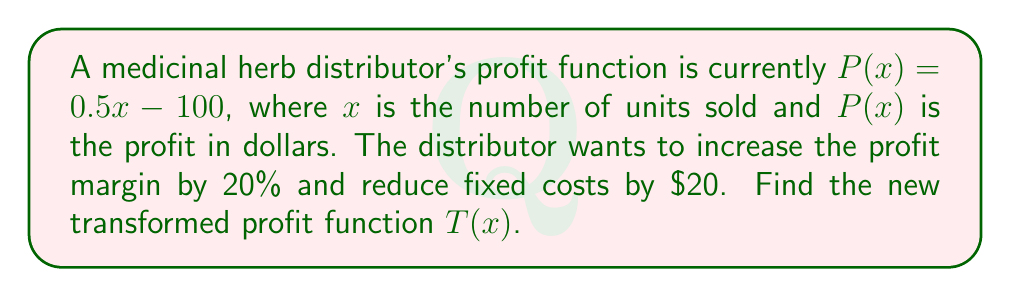Provide a solution to this math problem. To solve this problem, we'll follow these steps:

1) The original profit function is $P(x) = 0.5x - 100$

2) To increase the profit margin by 20%, we need to multiply the coefficient of $x$ by 1.20:
   $0.5 \times 1.20 = 0.6$

3) To reduce fixed costs by $20, we need to add 20 to the constant term (since it's currently negative):
   $-100 + 20 = -80$

4) The new transformed function $T(x)$ will have the form:
   $T(x) = 0.6x - 80$

5) We can verify that this transformation achieves the desired changes:
   - The coefficient of $x$ increased from 0.5 to 0.6 (a 20% increase)
   - The constant term changed from -100 to -80 (a $20 reduction in fixed costs)

Therefore, the new transformed profit function is $T(x) = 0.6x - 80$.
Answer: $T(x) = 0.6x - 80$ 